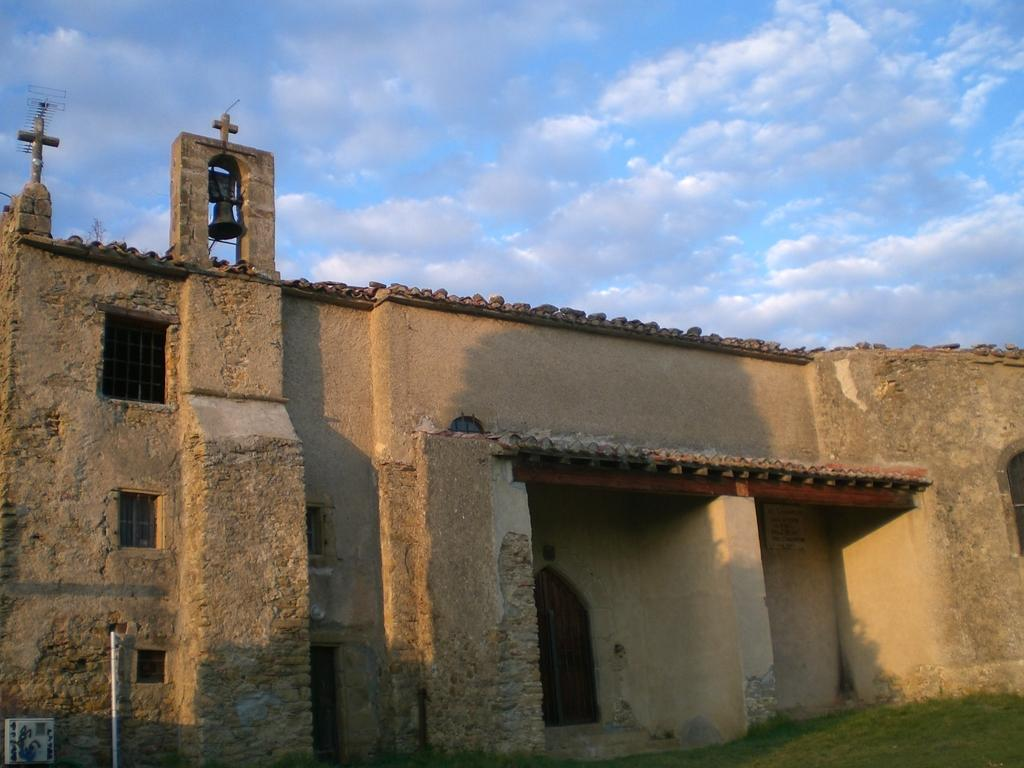What structure is located in the foreground of the image? There is a building in the foreground of the image. What type of vegetation is at the bottom of the image? Grass is present at the bottom of the image. What can be seen on the roof of the building? There is a bell and a cross symbol on the roof of the building. What is visible at the top of the image? The sky is visible at the top of the image. Can you see any waves or boats in the image? No, there are no waves or boats present in the image. 